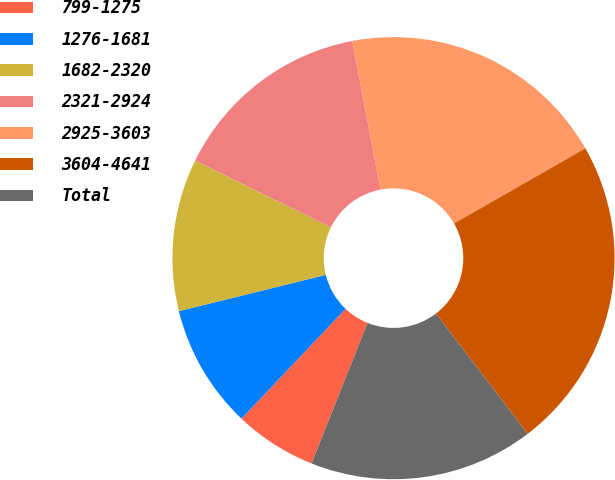Convert chart to OTSL. <chart><loc_0><loc_0><loc_500><loc_500><pie_chart><fcel>799-1275<fcel>1276-1681<fcel>1682-2320<fcel>2321-2924<fcel>2925-3603<fcel>3604-4641<fcel>Total<nl><fcel>6.02%<fcel>9.08%<fcel>11.13%<fcel>14.74%<fcel>19.71%<fcel>22.89%<fcel>16.43%<nl></chart> 